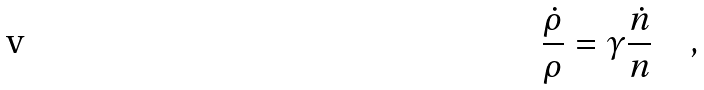<formula> <loc_0><loc_0><loc_500><loc_500>\frac { \dot { \rho } } { \rho } = { \gamma } \frac { \dot { n } } { n } \quad ,</formula> 